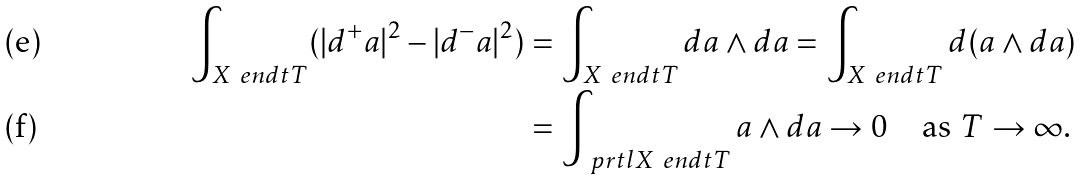<formula> <loc_0><loc_0><loc_500><loc_500>\int _ { X \ e n d t T } ( | d ^ { + } a | ^ { 2 } - | d ^ { - } a | ^ { 2 } ) & = \int _ { X \ e n d t T } d a \wedge d a = \int _ { X \ e n d t T } d ( a \wedge d a ) \\ & = \int _ { \ p r t l X \ e n d t T } a \wedge d a \to 0 \quad \text {as $T\to\infty$.}</formula> 